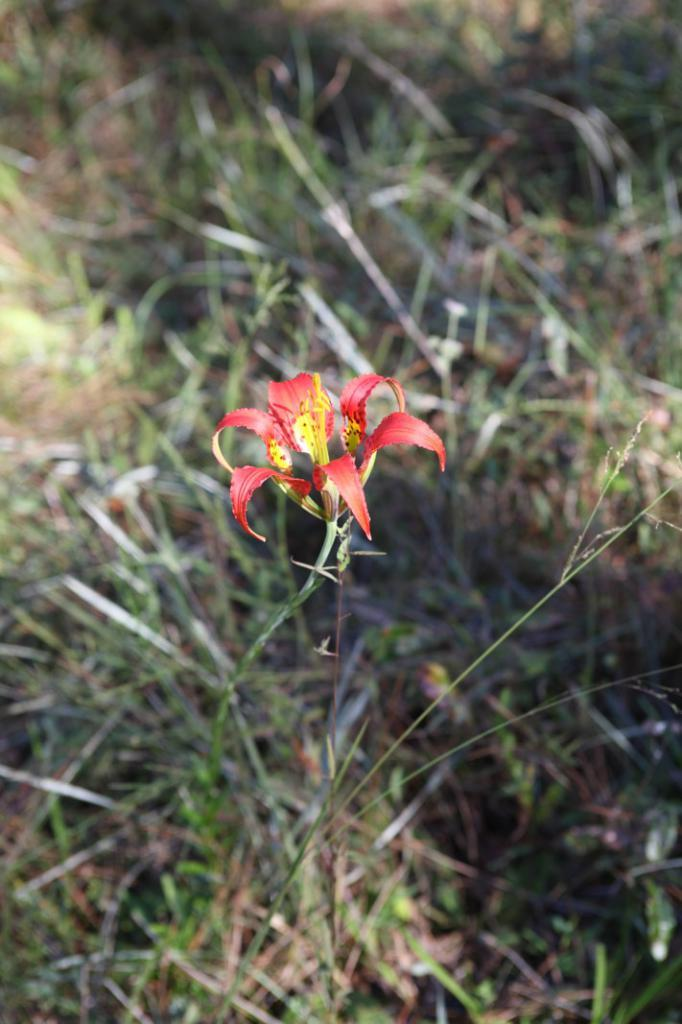What color is the flower on the plant in the image? The flower on the plant is red. What type of vegetation is at the bottom of the image? There is grass at the bottom of the image. What type of soil is visible in the image? There is mud in the image. What type of berry can be seen growing on the plant in the image? There is no berry present on the plant in the image; it has a red flower. 